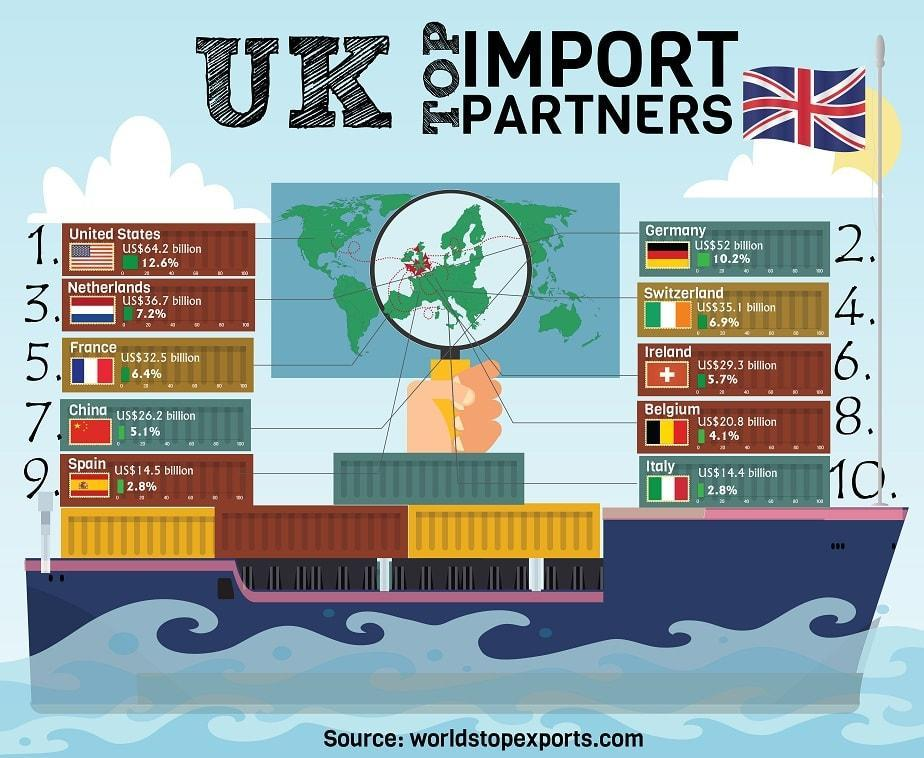Which country is the top import partner of UK?
Answer the question with a short phrase. United States What is the percentage of imports made to Netherlands by UK? 7.2% What is the percentage of imports made to Germany by UK? 10.2% 